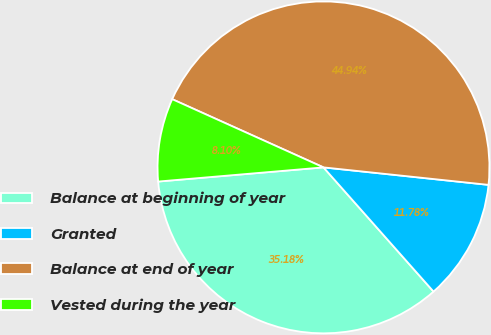Convert chart. <chart><loc_0><loc_0><loc_500><loc_500><pie_chart><fcel>Balance at beginning of year<fcel>Granted<fcel>Balance at end of year<fcel>Vested during the year<nl><fcel>35.18%<fcel>11.78%<fcel>44.94%<fcel>8.1%<nl></chart> 